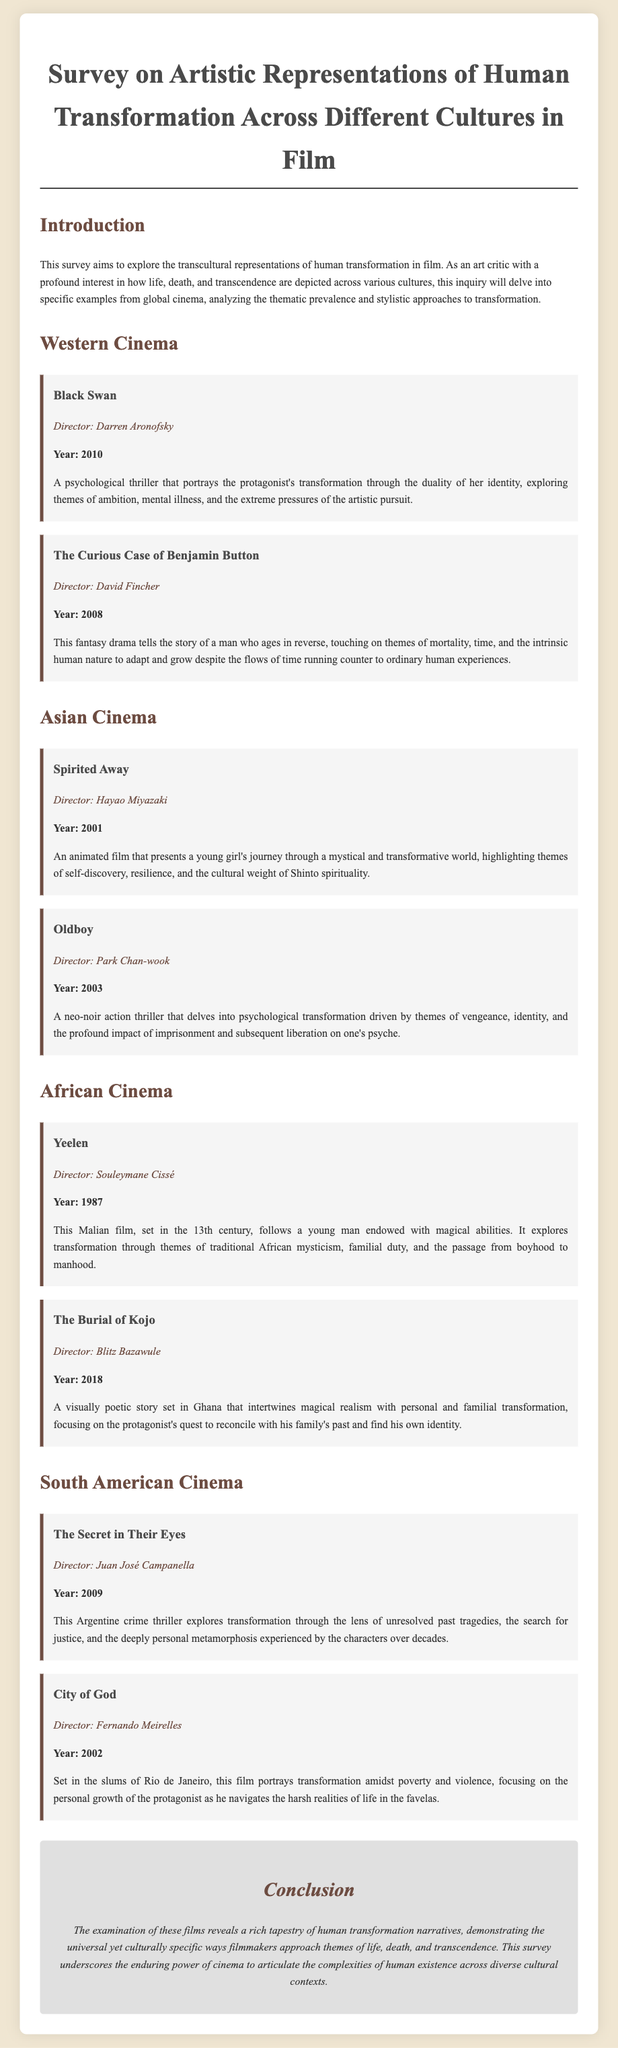what is the title of the survey? The title is the main heading presented at the top of the document, which describes the subject of the inquiry.
Answer: Survey on Artistic Representations of Human Transformation Across Different Cultures in Film who directed "Black Swan"? The director's name is listed under the film title in the section about Western Cinema, providing credit to the filmmaker.
Answer: Darren Aronofsky what year was "The Curious Case of Benjamin Button" released? The release year is indicated in bold below the film title, which serves to contextualize the film within a specific timeframe.
Answer: 2008 which film from Asian Cinema features a young girl's journey? The description under the Asian Cinema section explains the plot focus and highlights the main character's experience.
Answer: Spirited Away what is the main theme addressed in "Yeelen"? The description for the film in the African Cinema section summarizes the primary focus and thematic elements of the story.
Answer: Traditional African mysticism which two films are listed under South American Cinema? The document contains sections separated by headings, detailing each film's title, director, and description, including films from South America.
Answer: The Secret in Their Eyes and City of God what cultural themes are explored in "Oldboy"? The description in the Asian Cinema section elaborates on the significant concepts central to the film's narrative and character development.
Answer: Vengeance, identity how does "The Burial of Kojo" address transformation? The description summarizes the film's plot and highlights the way it entwines personal and familial transformations.
Answer: Magical realism and personal transformation what genre is "The Secret in Their Eyes"? This information can be derived from the description that articulates the tone and context of the narrative being portrayed in the film.
Answer: Crime thriller 